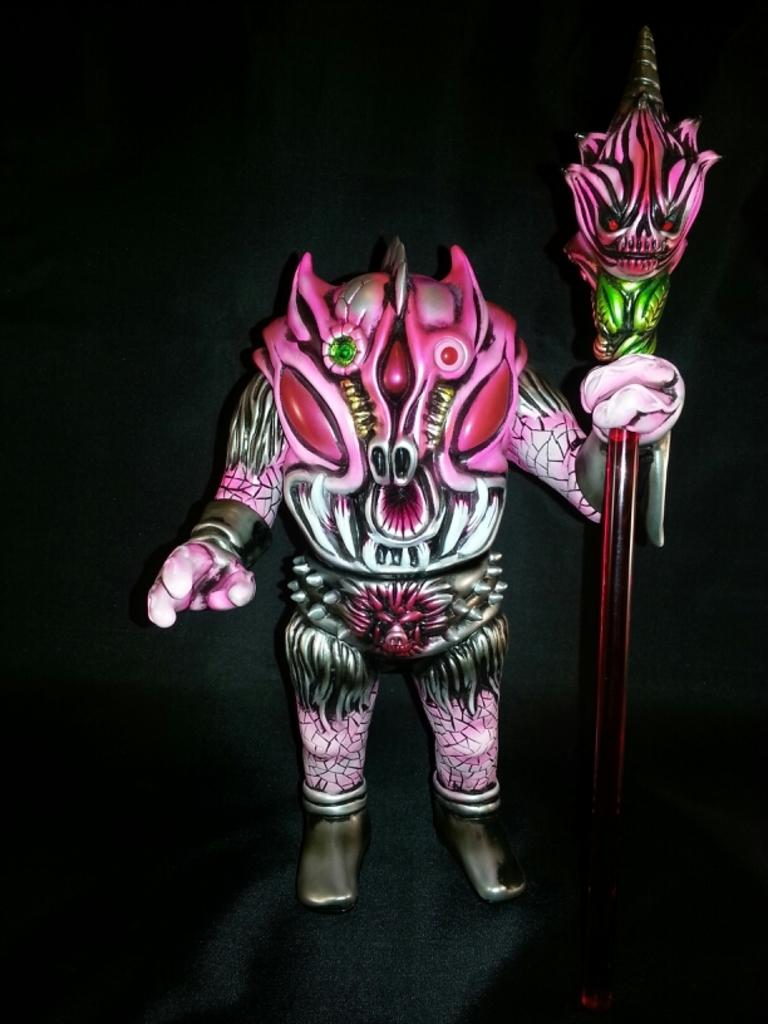What is the main subject of the image? The main subject of the image is a demon. What is the demon holding in the image? The demon is holding an object. How does the demon provide comfort to the governor in the image? There is no governor present in the image, and the demon's actions or intentions are not specified. 